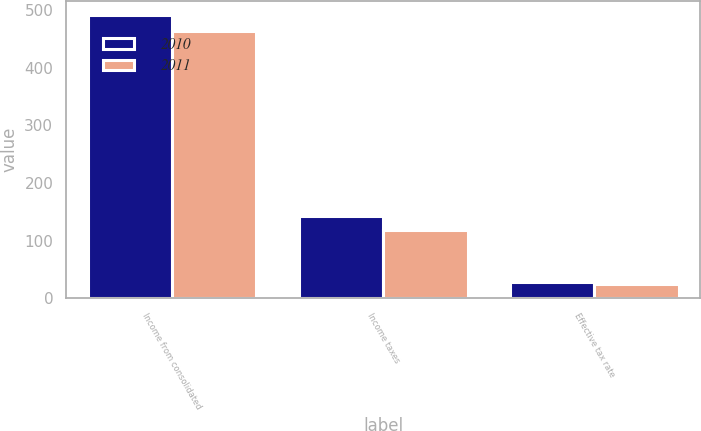Convert chart. <chart><loc_0><loc_0><loc_500><loc_500><stacked_bar_chart><ecel><fcel>Income from consolidated<fcel>Income taxes<fcel>Effective tax rate<nl><fcel>2010<fcel>491.4<fcel>142.6<fcel>29<nl><fcel>2011<fcel>462.7<fcel>118<fcel>25.5<nl></chart> 